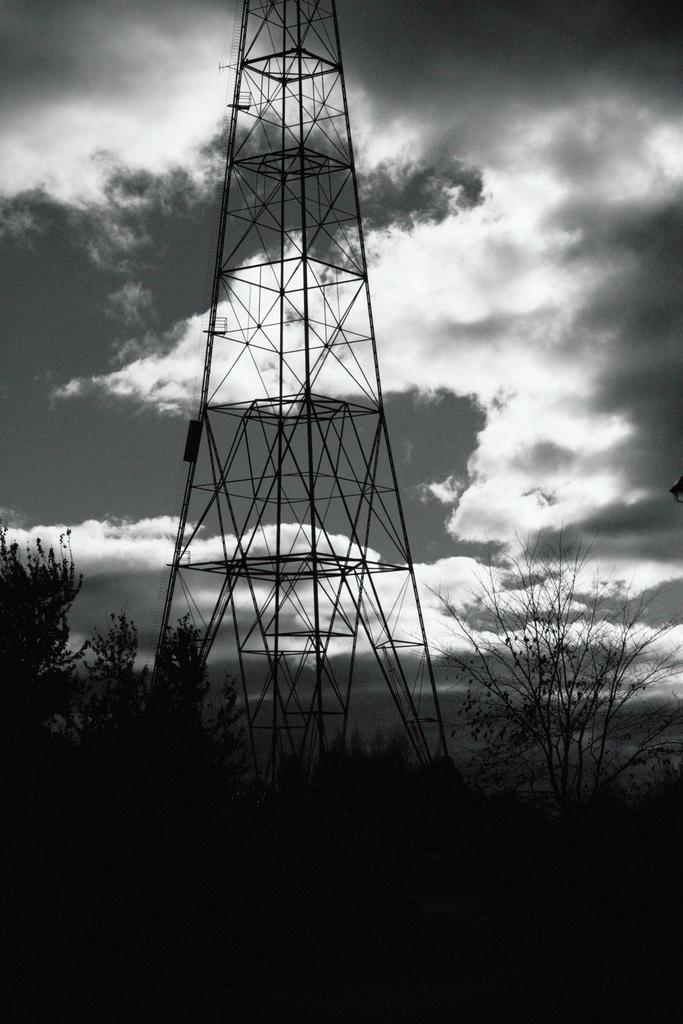What is the main structure in the image? There is a tower in the image. What can be seen in the background of the image? There are trees in the background of the image. How would you describe the sky in the image? The sky is cloudy in the image. What type of farm can be seen in the image? There is no farm present in the image; it features a tower and trees in the background. What kind of coil is used to support the tower in the image? There is no coil mentioned or visible in the image; the tower stands on its own. 